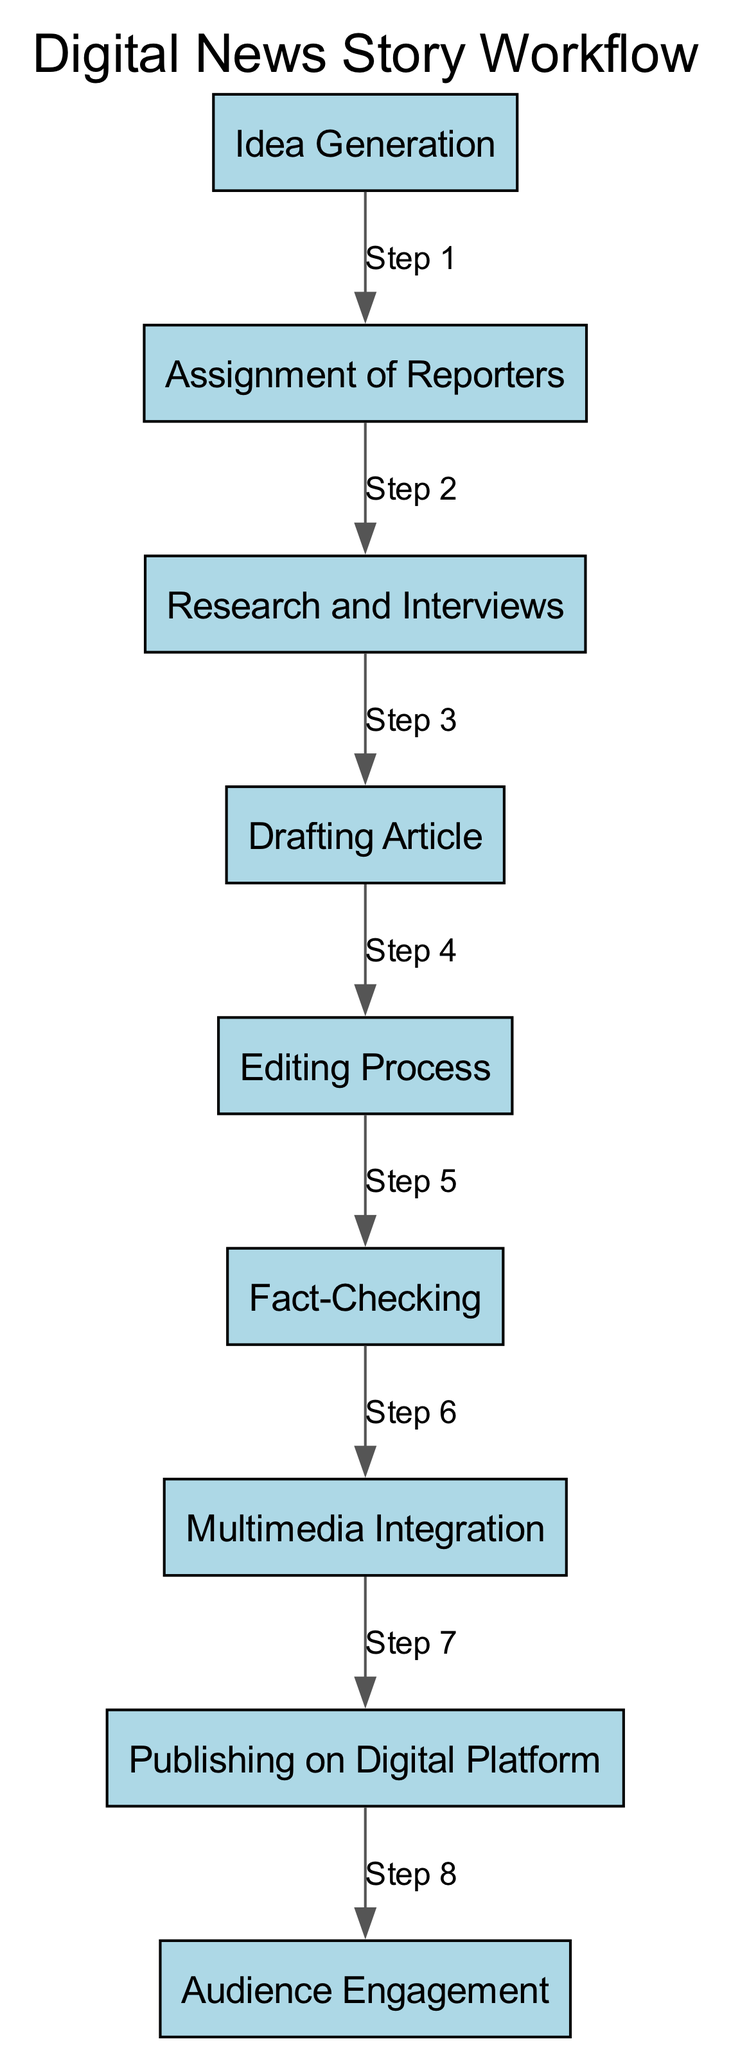What's the first activity in the workflow? The diagram starts with the first node labeled "Idea Generation." This indicates the beginning of the news story workflow where the editorial team discusses potential news stories.
Answer: Idea Generation How many activities are there in the workflow? The diagram includes a total of nine distinct activities listed sequentially. By counting each node, we find that there are nine activities in total.
Answer: Nine What is the last activity before publishing? The activity immediately preceding "Publishing on Digital Platform" is labeled "Multimedia Integration." This indicates that multimedia elements are integrated just before the article is published.
Answer: Multimedia Integration Which activity involves verification of information? "Fact-Checking" is the specific activity dedicated to verifying the accuracy of the information collected during the reporting process.
Answer: Fact-Checking What follows the editing process in the sequence? After the "Editing Process," the next step in the sequence is "Fact-Checking," which indicates that fact verification takes place after editing.
Answer: Fact-Checking In what order do audience interactions occur? "Audience Engagement" is the final activity in the workflow that occurs after "Publishing on Digital Platform," indicating that readers begin to interact with the article after it has been published.
Answer: After publishing Which two activities are directly connected by an edge labeled "Step 6"? "Editing Process" and "Fact-Checking" are directly connected by the sixth step in the sequence, which shows the order of activities as they are carried out.
Answer: Editing Process and Fact-Checking What represents the action of reporters gathering information? The node labeled "Research and Interviews" represents the action where reporters actively gather information and conduct interviews for the news story.
Answer: Research and Interviews What is the main purpose of the "Multimedia Integration" activity? The purpose of "Multimedia Integration" is to incorporate images, videos, and graphics into the article, enhancing its visual appeal before publication.
Answer: Incorporation of images, videos, and graphics 